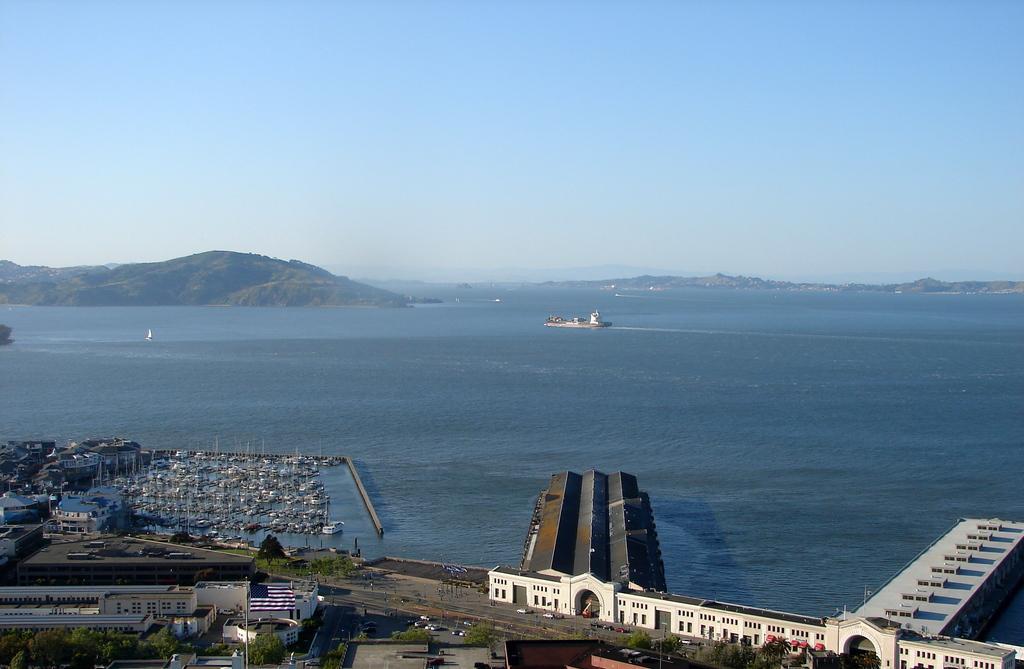In one or two sentences, can you explain what this image depicts? In this image I can see water. There are buildings, trees, vehicles, boats, poles, hills and in the background there is sky. 